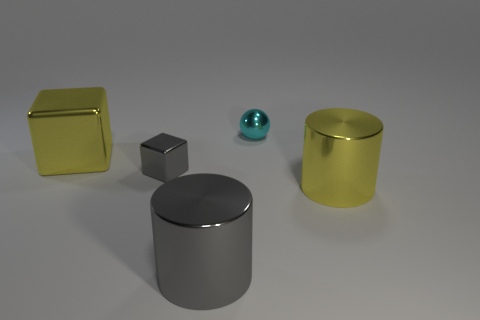What number of other objects are there of the same size as the cyan metallic sphere?
Provide a short and direct response. 1. How many metal things are both left of the metallic sphere and on the right side of the big gray metal thing?
Offer a terse response. 0. Does the cylinder that is behind the gray cylinder have the same size as the metallic block that is to the right of the large metallic block?
Make the answer very short. No. There is a gray metal thing behind the big gray cylinder; how big is it?
Your response must be concise. Small. What number of objects are yellow objects that are on the right side of the large gray metal thing or yellow metal things behind the small block?
Offer a terse response. 2. Is there anything else of the same color as the large shiny block?
Your answer should be very brief. Yes. Are there the same number of shiny spheres that are in front of the big metallic cube and yellow objects to the left of the yellow cylinder?
Make the answer very short. No. Are there more yellow cylinders right of the small gray cube than small red shiny cylinders?
Provide a succinct answer. Yes. What number of objects are objects right of the small cyan sphere or small shiny objects?
Ensure brevity in your answer.  3. How many big yellow cylinders have the same material as the yellow block?
Make the answer very short. 1. 